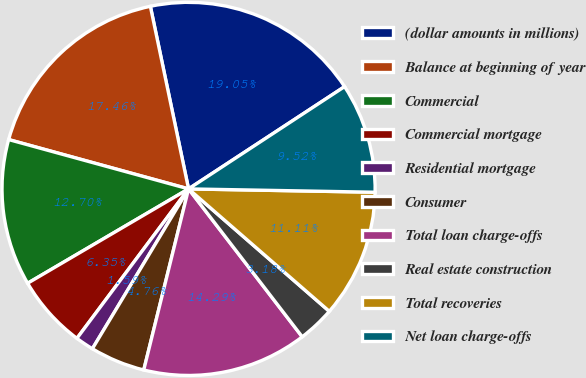<chart> <loc_0><loc_0><loc_500><loc_500><pie_chart><fcel>(dollar amounts in millions)<fcel>Balance at beginning of year<fcel>Commercial<fcel>Commercial mortgage<fcel>Residential mortgage<fcel>Consumer<fcel>Total loan charge-offs<fcel>Real estate construction<fcel>Total recoveries<fcel>Net loan charge-offs<nl><fcel>19.05%<fcel>17.46%<fcel>12.7%<fcel>6.35%<fcel>1.59%<fcel>4.76%<fcel>14.29%<fcel>3.18%<fcel>11.11%<fcel>9.52%<nl></chart> 